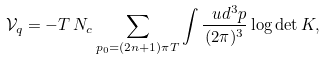<formula> <loc_0><loc_0><loc_500><loc_500>\mathcal { V } _ { q } = - T \, N _ { c } \sum _ { p _ { 0 } = ( 2 n + 1 ) \pi T } \int \frac { \ u d ^ { 3 } p } { ( 2 \pi ) ^ { 3 } } \log \det K ,</formula> 